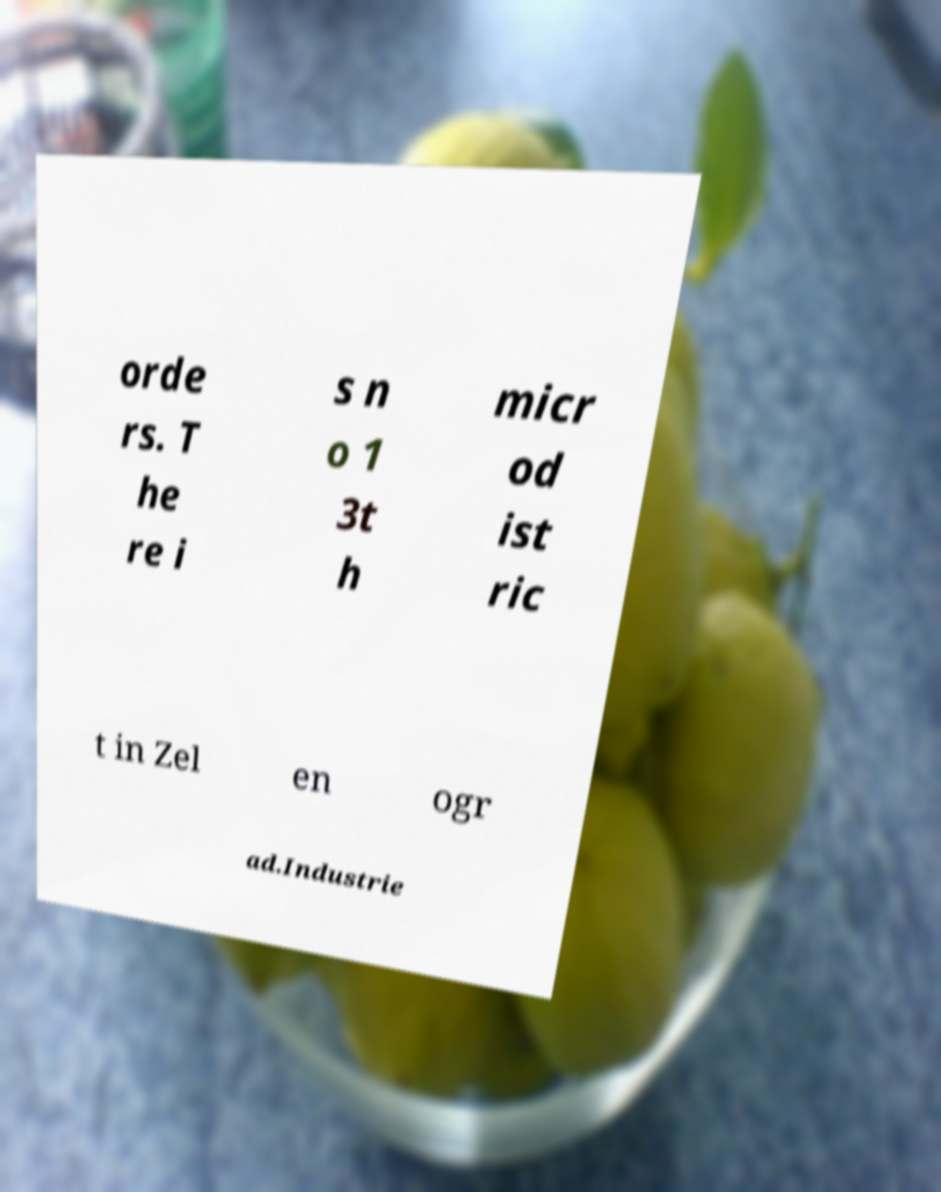Can you accurately transcribe the text from the provided image for me? orde rs. T he re i s n o 1 3t h micr od ist ric t in Zel en ogr ad.Industrie 